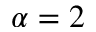Convert formula to latex. <formula><loc_0><loc_0><loc_500><loc_500>\alpha = 2</formula> 